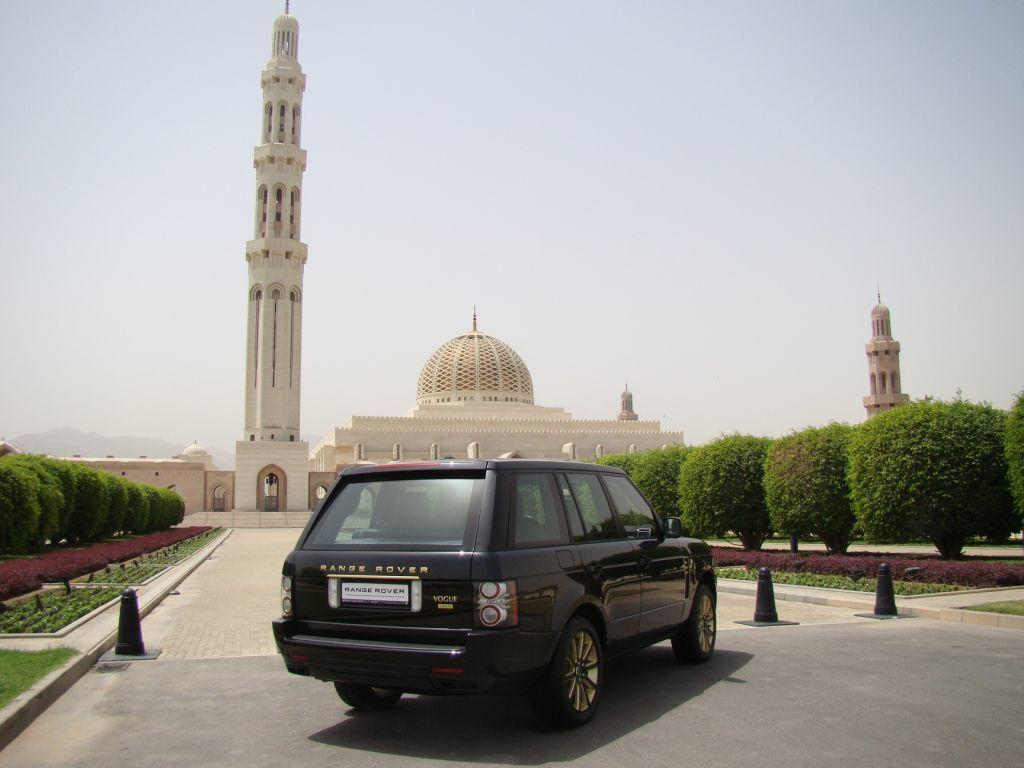<image>
Describe the image concisely. black range rover sits parked next to a nice builfing 